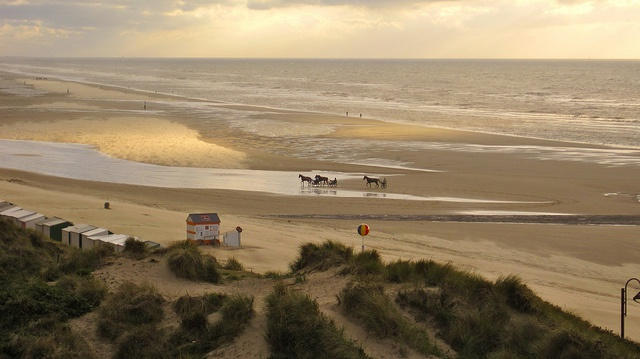Describe the objects in this image and their specific colors. I can see horse in darkgray, black, gray, and maroon tones, horse in darkgray, maroon, black, and gray tones, horse in darkgray, black, maroon, and gray tones, horse in darkgray, black, gray, and maroon tones, and horse in darkgray, black, and gray tones in this image. 